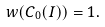Convert formula to latex. <formula><loc_0><loc_0><loc_500><loc_500>w ( C _ { 0 } ( I ) ) = 1 .</formula> 